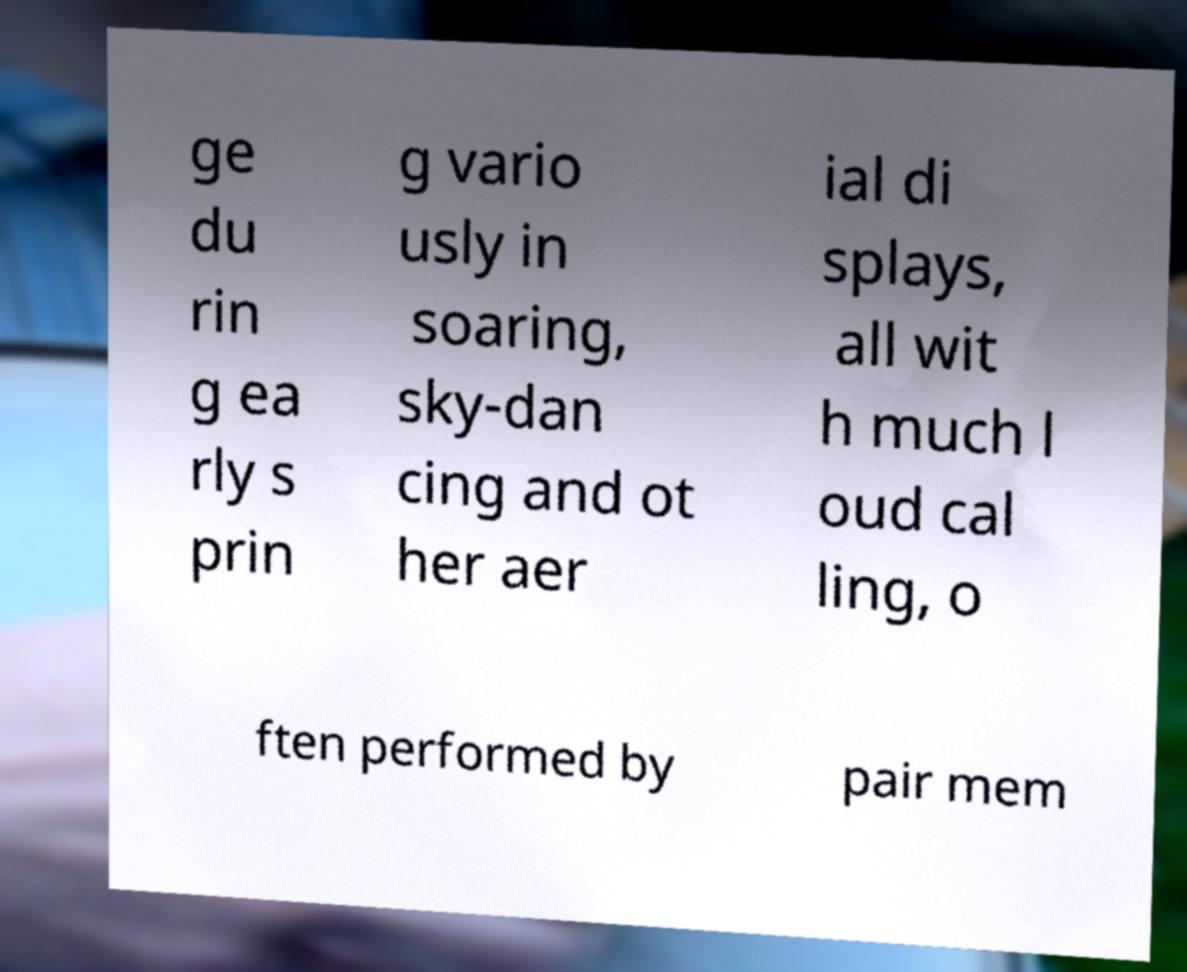What messages or text are displayed in this image? I need them in a readable, typed format. ge du rin g ea rly s prin g vario usly in soaring, sky-dan cing and ot her aer ial di splays, all wit h much l oud cal ling, o ften performed by pair mem 